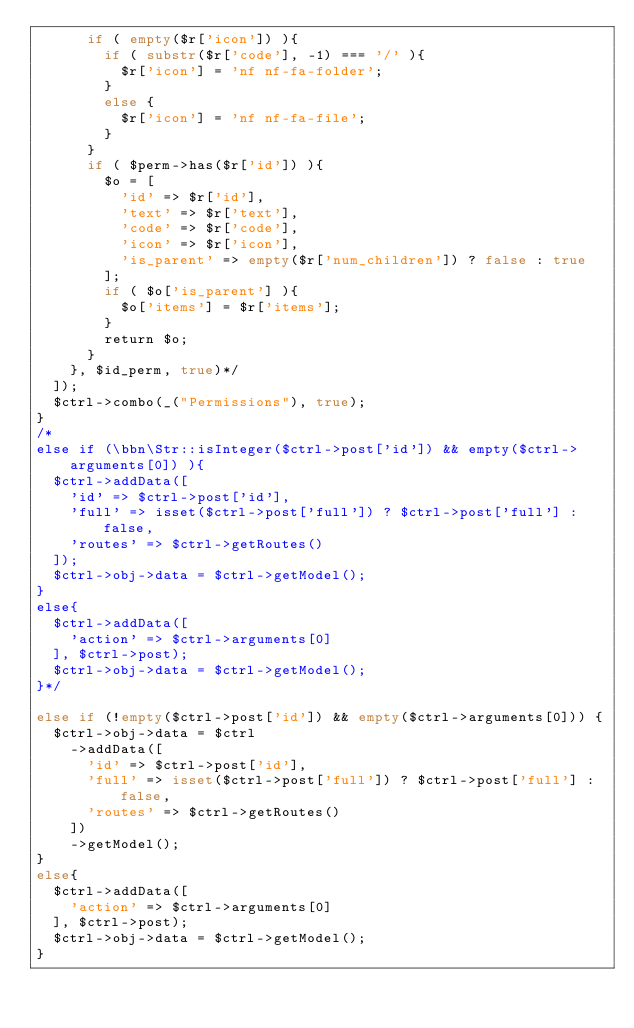Convert code to text. <code><loc_0><loc_0><loc_500><loc_500><_PHP_>      if ( empty($r['icon']) ){
        if ( substr($r['code'], -1) === '/' ){
          $r['icon'] = 'nf nf-fa-folder';
        }
        else {
          $r['icon'] = 'nf nf-fa-file';
        }
      }
      if ( $perm->has($r['id']) ){
        $o = [
          'id' => $r['id'],
          'text' => $r['text'],
          'code' => $r['code'],
          'icon' => $r['icon'],
          'is_parent' => empty($r['num_children']) ? false : true
        ];
        if ( $o['is_parent'] ){
          $o['items'] = $r['items'];
        }
        return $o;
      }
    }, $id_perm, true)*/
  ]);
  $ctrl->combo(_("Permissions"), true);
}
/*
else if (\bbn\Str::isInteger($ctrl->post['id']) && empty($ctrl->arguments[0]) ){
  $ctrl->addData([
    'id' => $ctrl->post['id'],
    'full' => isset($ctrl->post['full']) ? $ctrl->post['full'] : false,
    'routes' => $ctrl->getRoutes()
  ]);
  $ctrl->obj->data = $ctrl->getModel();
}
else{
  $ctrl->addData([
    'action' => $ctrl->arguments[0]
  ], $ctrl->post);
  $ctrl->obj->data = $ctrl->getModel();
}*/

else if (!empty($ctrl->post['id']) && empty($ctrl->arguments[0])) {
  $ctrl->obj->data = $ctrl
    ->addData([
      'id' => $ctrl->post['id'],
      'full' => isset($ctrl->post['full']) ? $ctrl->post['full'] : false,
      'routes' => $ctrl->getRoutes()
    ])
    ->getModel();
}
else{
  $ctrl->addData([
    'action' => $ctrl->arguments[0]
  ], $ctrl->post);
  $ctrl->obj->data = $ctrl->getModel();
}</code> 